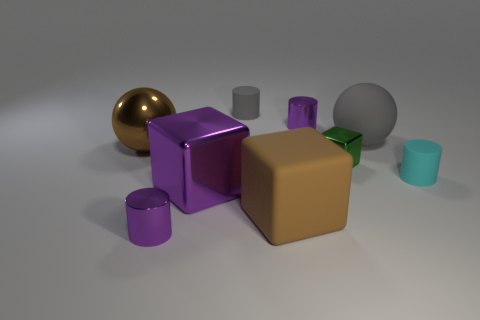Subtract 1 cylinders. How many cylinders are left? 3 Add 1 green cylinders. How many objects exist? 10 Subtract all blocks. How many objects are left? 6 Subtract all gray matte things. Subtract all small gray cylinders. How many objects are left? 6 Add 1 green blocks. How many green blocks are left? 2 Add 4 small red metal things. How many small red metal things exist? 4 Subtract 0 red cylinders. How many objects are left? 9 